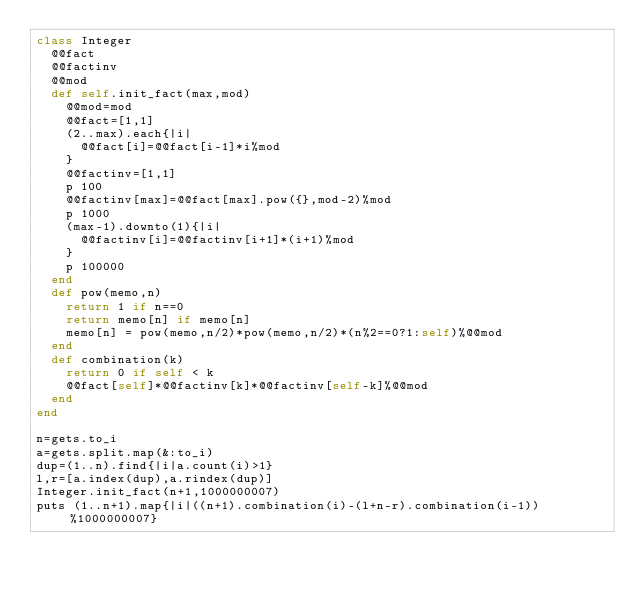<code> <loc_0><loc_0><loc_500><loc_500><_Ruby_>class Integer
  @@fact
  @@factinv
  @@mod
  def self.init_fact(max,mod)
    @@mod=mod
    @@fact=[1,1]
    (2..max).each{|i|
      @@fact[i]=@@fact[i-1]*i%mod
    }
    @@factinv=[1,1]
    p 100
    @@factinv[max]=@@fact[max].pow({},mod-2)%mod
    p 1000
    (max-1).downto(1){|i|
      @@factinv[i]=@@factinv[i+1]*(i+1)%mod
    }
    p 100000
  end
  def pow(memo,n)
    return 1 if n==0
    return memo[n] if memo[n]
    memo[n] = pow(memo,n/2)*pow(memo,n/2)*(n%2==0?1:self)%@@mod
  end
  def combination(k)
    return 0 if self < k
    @@fact[self]*@@factinv[k]*@@factinv[self-k]%@@mod
  end
end

n=gets.to_i
a=gets.split.map(&:to_i)
dup=(1..n).find{|i|a.count(i)>1}
l,r=[a.index(dup),a.rindex(dup)]
Integer.init_fact(n+1,1000000007)
puts (1..n+1).map{|i|((n+1).combination(i)-(l+n-r).combination(i-1))%1000000007}
</code> 